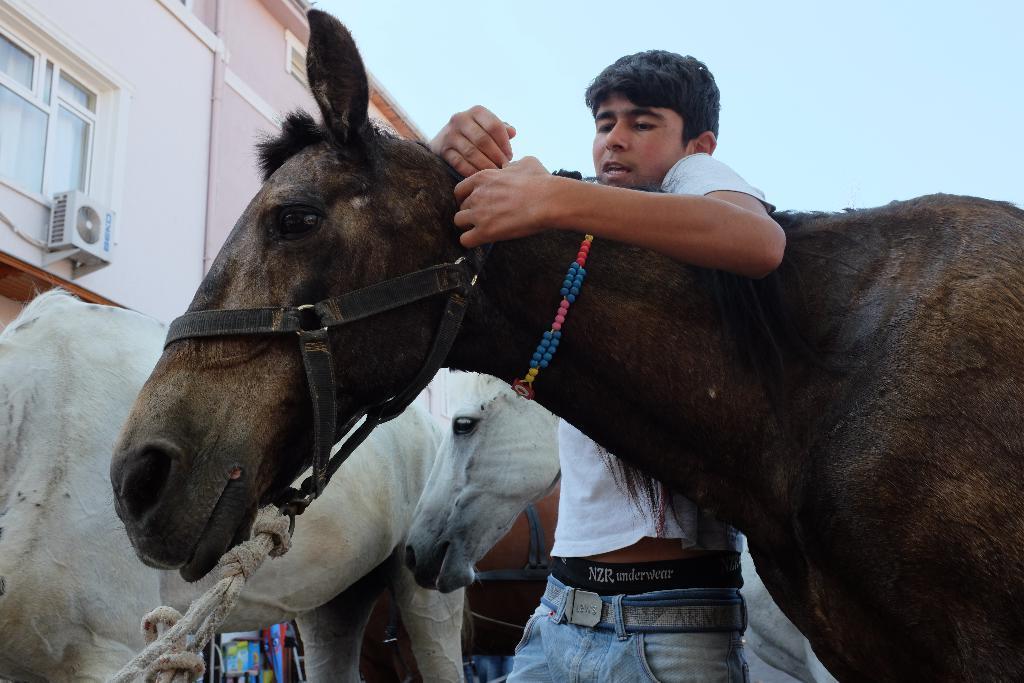In one or two sentences, can you explain what this image depicts? At the top we can see sky. This is a building, windows. Here we can see few horses in black and white colour. We can see one man laid his hands over a horse. 